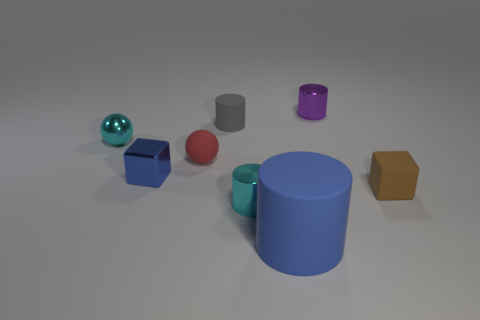Subtract all yellow cylinders. Subtract all red cubes. How many cylinders are left? 4 Add 1 small blue things. How many objects exist? 9 Subtract all spheres. How many objects are left? 6 Add 2 large cylinders. How many large cylinders exist? 3 Subtract 0 purple cubes. How many objects are left? 8 Subtract all big objects. Subtract all rubber things. How many objects are left? 3 Add 7 gray cylinders. How many gray cylinders are left? 8 